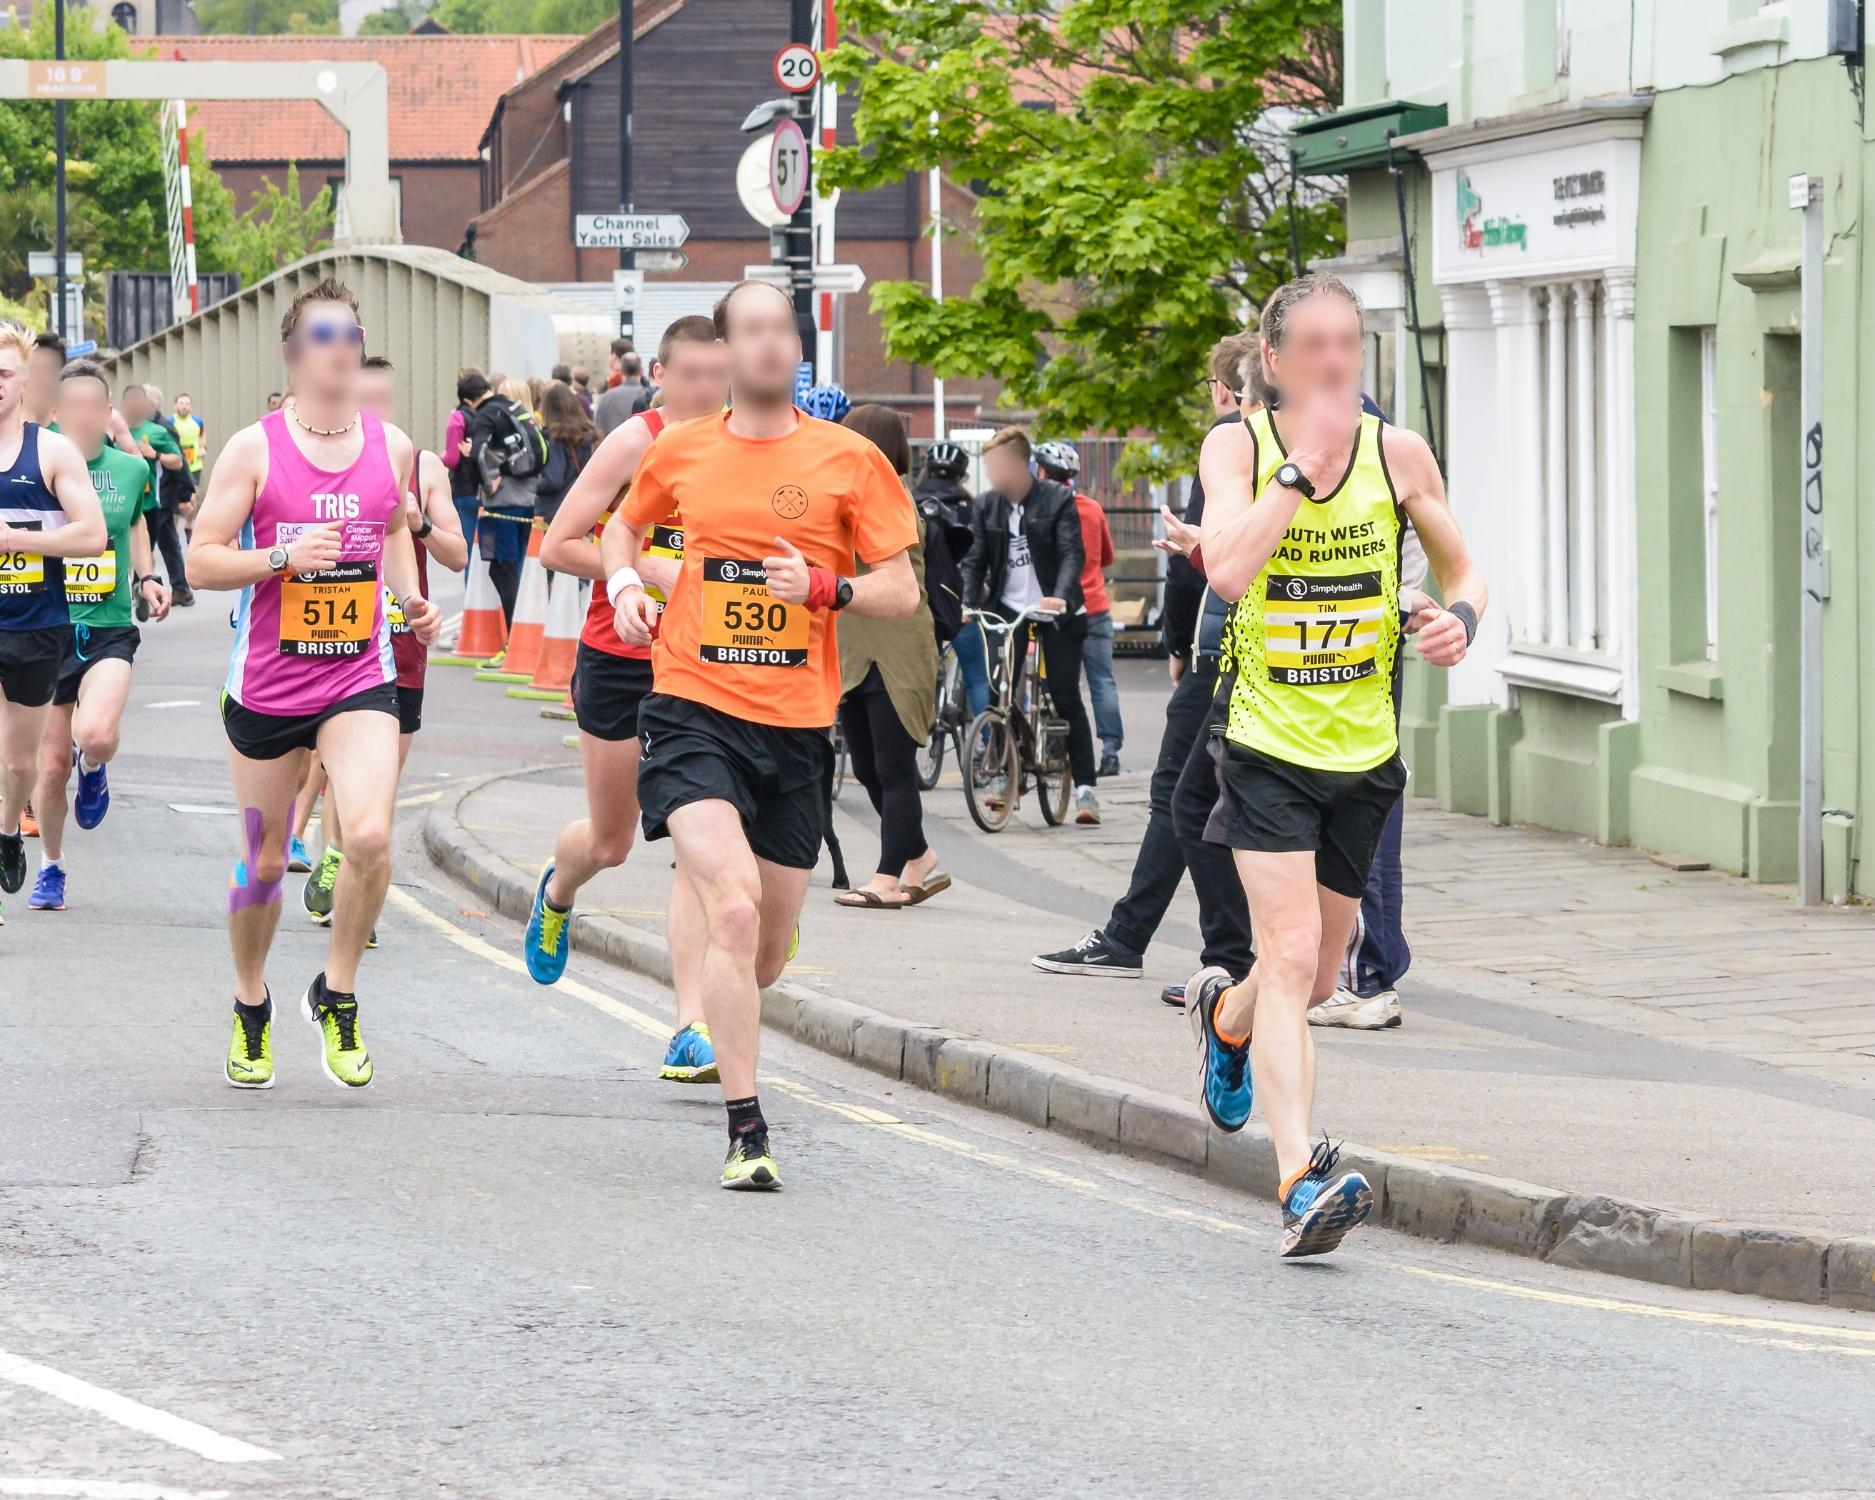Can we make any assumptions about the location of this race? Based on the architecture of the buildings and signage that can be partially seen, as well as the style of clothes and appearance of the participants, it's likely that this race is taking place in a Western country. However, without specific landmarks or symbols, it would be difficult to pinpoint the exact location. Are there any indications of the competitiveness of the race? Competitiveness can be inferred from the participants' focused facial expressions and athletic attire. The numbers on their bibs suggest that it's a timed race, where runners are likely trying to achieve personal bests or qualify for further competitions. Additionally, the spread out grouping of runners indicates varying paces and levels of competitiveness. 